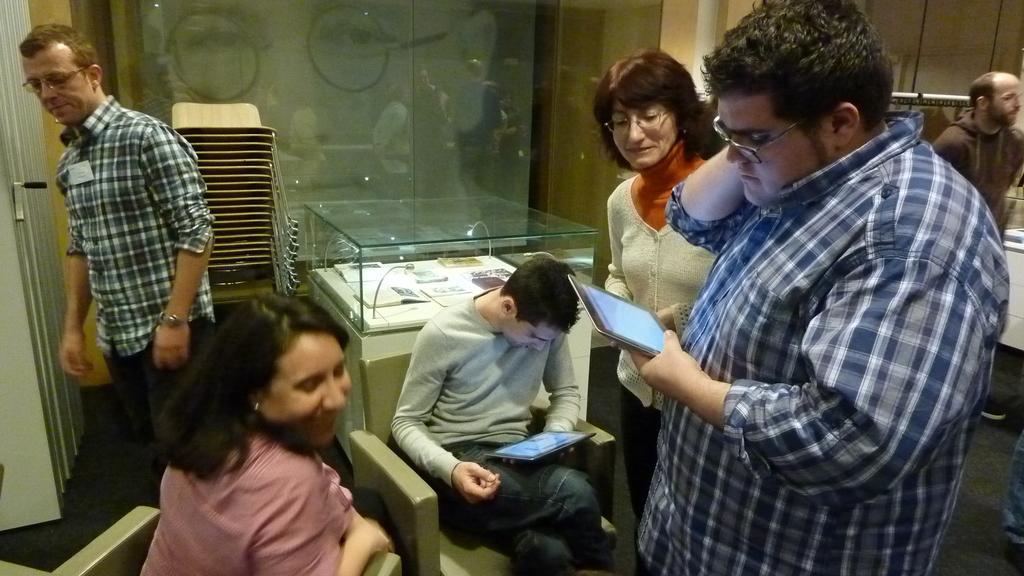Describe this image in one or two sentences. In this image, I can see two persons sitting on the chairs and four persons standing. In the background, I can see chairs, a glass door and books in a glass box. On the left side of the image, It looks like a door. 